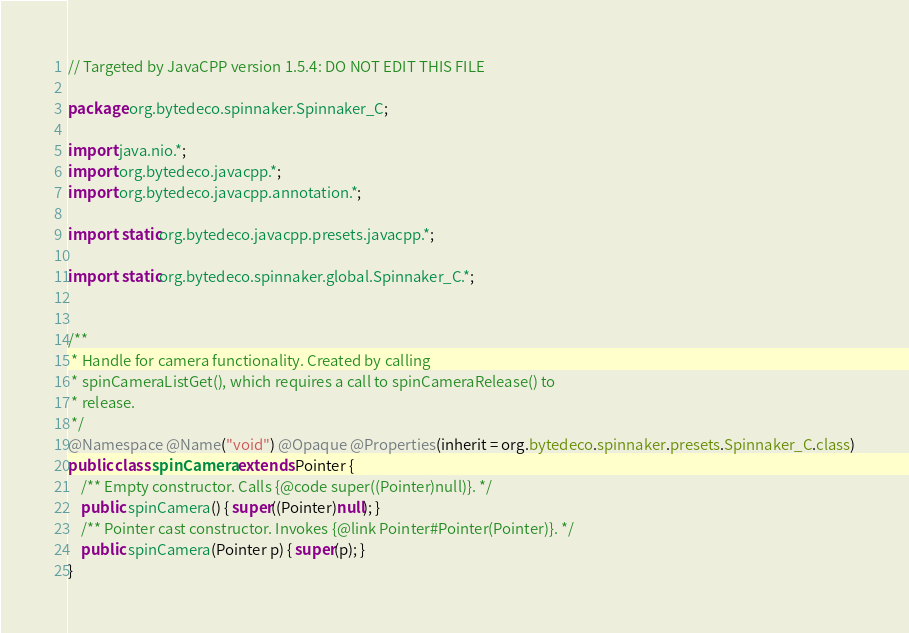Convert code to text. <code><loc_0><loc_0><loc_500><loc_500><_Java_>// Targeted by JavaCPP version 1.5.4: DO NOT EDIT THIS FILE

package org.bytedeco.spinnaker.Spinnaker_C;

import java.nio.*;
import org.bytedeco.javacpp.*;
import org.bytedeco.javacpp.annotation.*;

import static org.bytedeco.javacpp.presets.javacpp.*;

import static org.bytedeco.spinnaker.global.Spinnaker_C.*;


/**
 * Handle for camera functionality. Created by calling
 * spinCameraListGet(), which requires a call to spinCameraRelease() to
 * release.
 */
@Namespace @Name("void") @Opaque @Properties(inherit = org.bytedeco.spinnaker.presets.Spinnaker_C.class)
public class spinCamera extends Pointer {
    /** Empty constructor. Calls {@code super((Pointer)null)}. */
    public spinCamera() { super((Pointer)null); }
    /** Pointer cast constructor. Invokes {@link Pointer#Pointer(Pointer)}. */
    public spinCamera(Pointer p) { super(p); }
}
</code> 